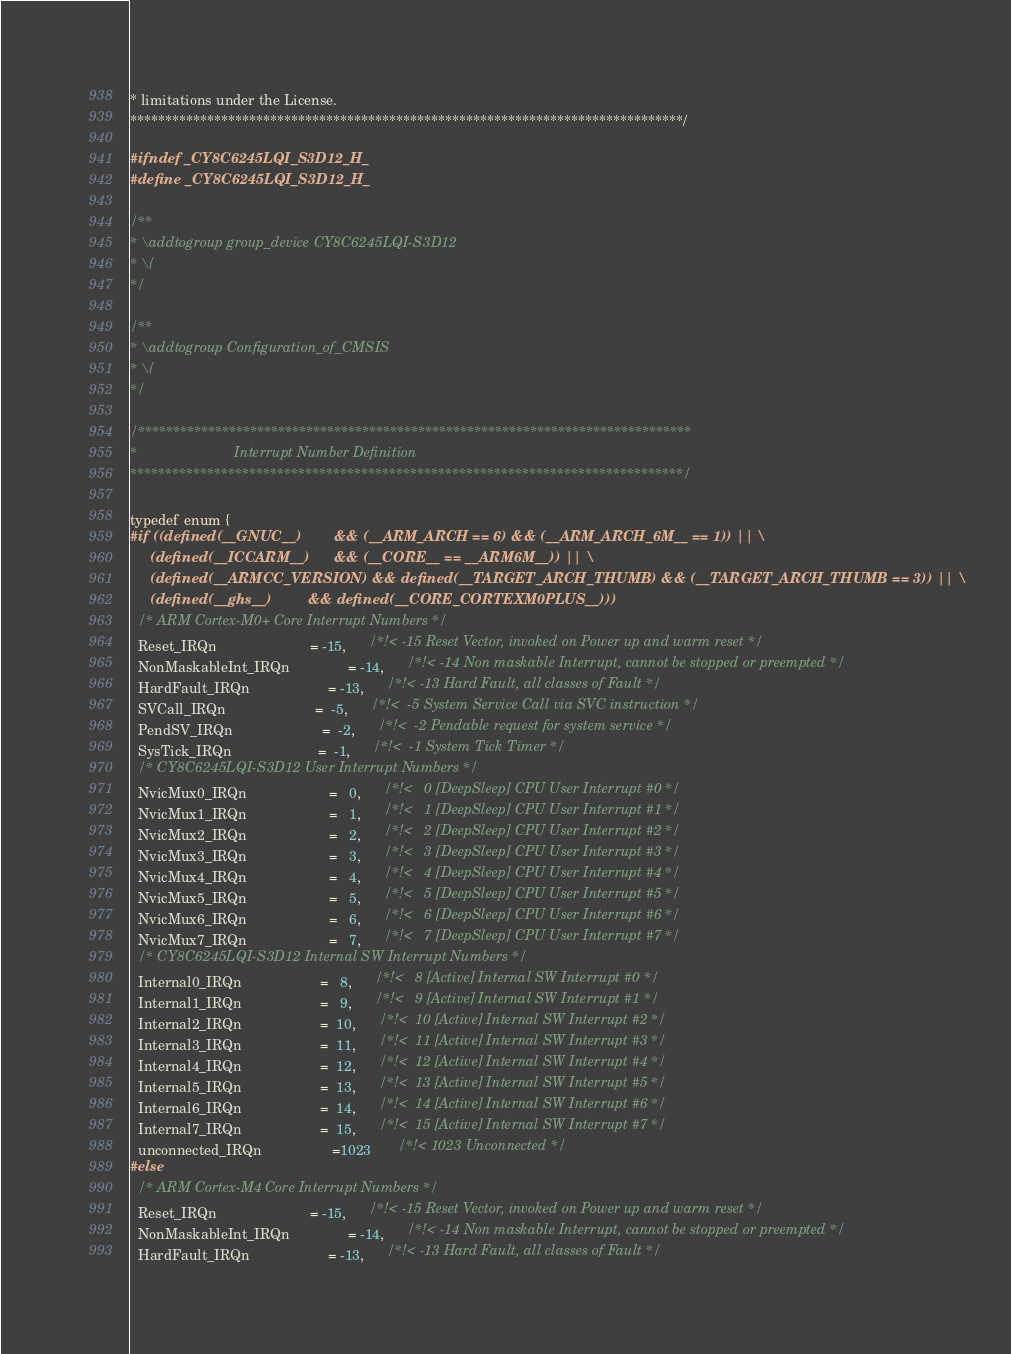Convert code to text. <code><loc_0><loc_0><loc_500><loc_500><_C_>* limitations under the License.
*******************************************************************************/

#ifndef _CY8C6245LQI_S3D12_H_
#define _CY8C6245LQI_S3D12_H_

/**
* \addtogroup group_device CY8C6245LQI-S3D12
* \{
*/

/**
* \addtogroup Configuration_of_CMSIS
* \{
*/

/*******************************************************************************
*                         Interrupt Number Definition
*******************************************************************************/

typedef enum {
#if ((defined(__GNUC__)        && (__ARM_ARCH == 6) && (__ARM_ARCH_6M__ == 1)) || \
     (defined(__ICCARM__)      && (__CORE__ == __ARM6M__)) || \
     (defined(__ARMCC_VERSION) && defined(__TARGET_ARCH_THUMB) && (__TARGET_ARCH_THUMB == 3)) || \
     (defined(__ghs__)         && defined(__CORE_CORTEXM0PLUS__)))
  /* ARM Cortex-M0+ Core Interrupt Numbers */
  Reset_IRQn                        = -15,      /*!< -15 Reset Vector, invoked on Power up and warm reset */
  NonMaskableInt_IRQn               = -14,      /*!< -14 Non maskable Interrupt, cannot be stopped or preempted */
  HardFault_IRQn                    = -13,      /*!< -13 Hard Fault, all classes of Fault */
  SVCall_IRQn                       =  -5,      /*!<  -5 System Service Call via SVC instruction */
  PendSV_IRQn                       =  -2,      /*!<  -2 Pendable request for system service */
  SysTick_IRQn                      =  -1,      /*!<  -1 System Tick Timer */
  /* CY8C6245LQI-S3D12 User Interrupt Numbers */
  NvicMux0_IRQn                     =   0,      /*!<   0 [DeepSleep] CPU User Interrupt #0 */
  NvicMux1_IRQn                     =   1,      /*!<   1 [DeepSleep] CPU User Interrupt #1 */
  NvicMux2_IRQn                     =   2,      /*!<   2 [DeepSleep] CPU User Interrupt #2 */
  NvicMux3_IRQn                     =   3,      /*!<   3 [DeepSleep] CPU User Interrupt #3 */
  NvicMux4_IRQn                     =   4,      /*!<   4 [DeepSleep] CPU User Interrupt #4 */
  NvicMux5_IRQn                     =   5,      /*!<   5 [DeepSleep] CPU User Interrupt #5 */
  NvicMux6_IRQn                     =   6,      /*!<   6 [DeepSleep] CPU User Interrupt #6 */
  NvicMux7_IRQn                     =   7,      /*!<   7 [DeepSleep] CPU User Interrupt #7 */
  /* CY8C6245LQI-S3D12 Internal SW Interrupt Numbers */
  Internal0_IRQn                    =   8,      /*!<   8 [Active] Internal SW Interrupt #0 */
  Internal1_IRQn                    =   9,      /*!<   9 [Active] Internal SW Interrupt #1 */
  Internal2_IRQn                    =  10,      /*!<  10 [Active] Internal SW Interrupt #2 */
  Internal3_IRQn                    =  11,      /*!<  11 [Active] Internal SW Interrupt #3 */
  Internal4_IRQn                    =  12,      /*!<  12 [Active] Internal SW Interrupt #4 */
  Internal5_IRQn                    =  13,      /*!<  13 [Active] Internal SW Interrupt #5 */
  Internal6_IRQn                    =  14,      /*!<  14 [Active] Internal SW Interrupt #6 */
  Internal7_IRQn                    =  15,      /*!<  15 [Active] Internal SW Interrupt #7 */
  unconnected_IRQn                  =1023       /*!< 1023 Unconnected */
#else
  /* ARM Cortex-M4 Core Interrupt Numbers */
  Reset_IRQn                        = -15,      /*!< -15 Reset Vector, invoked on Power up and warm reset */
  NonMaskableInt_IRQn               = -14,      /*!< -14 Non maskable Interrupt, cannot be stopped or preempted */
  HardFault_IRQn                    = -13,      /*!< -13 Hard Fault, all classes of Fault */</code> 